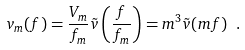<formula> <loc_0><loc_0><loc_500><loc_500>v _ { m } ( f ) = \frac { V _ { m } } { f _ { m } } \tilde { v } \left ( \frac { f } { f _ { m } } \right ) = m ^ { 3 } \tilde { v } ( m f ) \ .</formula> 